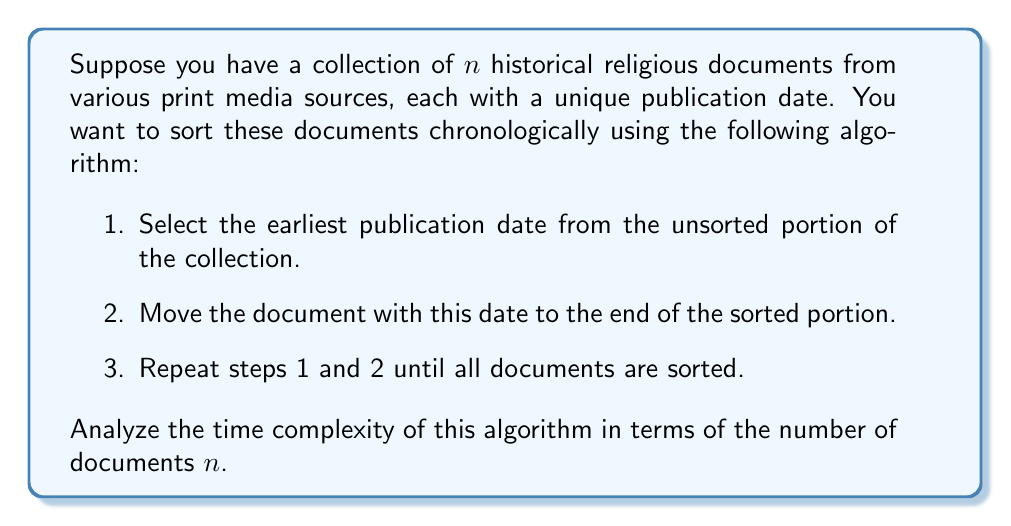Could you help me with this problem? Let's analyze this algorithm step by step:

1. The algorithm is essentially a selection sort, where we repeatedly find the minimum element (earliest publication date) and place it at the end of the sorted portion.

2. In the first iteration, we need to examine all $n$ documents to find the earliest publication date.

3. In the second iteration, we need to examine $n-1$ documents, as one document is already sorted.

4. This pattern continues, with each subsequent iteration examining one fewer document.

5. The number of comparisons in each iteration can be represented as:
   $n + (n-1) + (n-2) + ... + 2 + 1$

6. This is an arithmetic series with $n$ terms, starting at 1 and ending at $n$.

7. The sum of this arithmetic series is given by the formula:
   $$\frac{n(n+1)}{2}$$

8. Expanding this, we get:
   $$\frac{n^2 + n}{2}$$

9. In Big O notation, we only consider the highest order term and drop the constant coefficient. Therefore, the time complexity is $O(n^2)$.

This quadratic time complexity means that as the number of documents increases, the time taken by the algorithm increases quadratically, making it inefficient for large collections of historical documents.
Answer: The time complexity of the algorithm is $O(n^2)$, where $n$ is the number of historical documents. 